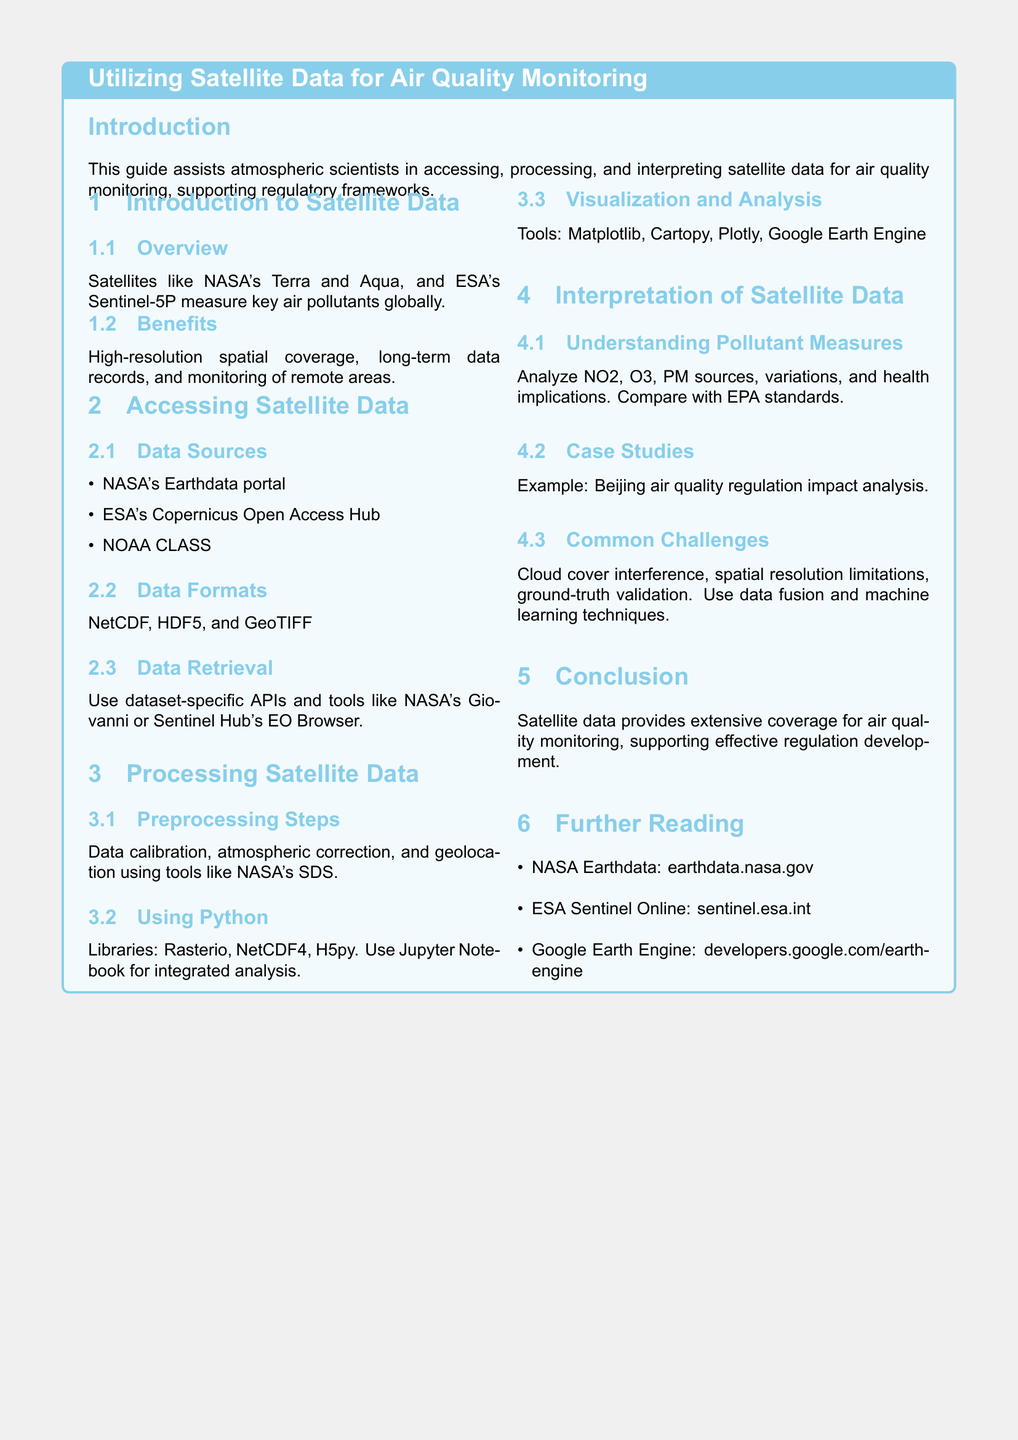What are some satellite data sources mentioned? The document lists various data sources including NASA's Earthdata portal, ESA's Copernicus Open Access Hub, and NOAA CLASS.
Answer: NASA's Earthdata portal, ESA's Copernicus Open Access Hub, NOAA CLASS What is one benefit of using satellite data for air quality monitoring? The guide states that a key benefit is high-resolution spatial coverage.
Answer: High-resolution spatial coverage Which library is mentioned for processing satellite data? The document mentions several libraries including Rasterio, NetCDF4, and H5py.
Answer: Rasterio What does the section on interpretation of satellite data focus on? This section focuses on understanding pollutant measures and their health implications.
Answer: Understanding pollutant measures What is a common challenge identified in the guide? The document lists cloud cover interference as one of the challenges faced when working with satellite data.
Answer: Cloud cover interference What tool can be used for visualization of satellite data? The document mentions several tools including Matplotlib, Cartopy, and Plotly for data visualization.
Answer: Matplotlib What are the data formats specified for satellite data? The document specifies formats like NetCDF, HDF5, and GeoTIFF for satellite data.
Answer: NetCDF, HDF5, GeoTIFF Which specific case study is referenced in the guide? The guide references an example related to Beijing's air quality regulation impact analysis.
Answer: Beijing air quality regulation impact analysis 